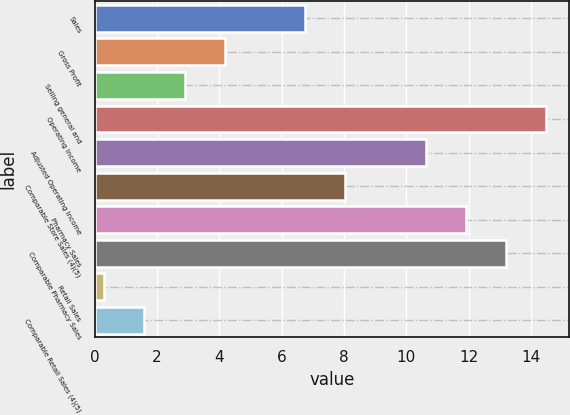Convert chart. <chart><loc_0><loc_0><loc_500><loc_500><bar_chart><fcel>Sales<fcel>Gross Profit<fcel>Selling general and<fcel>Operating Income<fcel>Adjusted Operating Income<fcel>Comparable Store Sales (4)(5)<fcel>Pharmacy Sales<fcel>Comparable Pharmacy Sales<fcel>Retail Sales<fcel>Comparable Retail Sales (4)(5)<nl><fcel>6.75<fcel>4.17<fcel>2.88<fcel>14.49<fcel>10.62<fcel>8.04<fcel>11.91<fcel>13.2<fcel>0.3<fcel>1.59<nl></chart> 